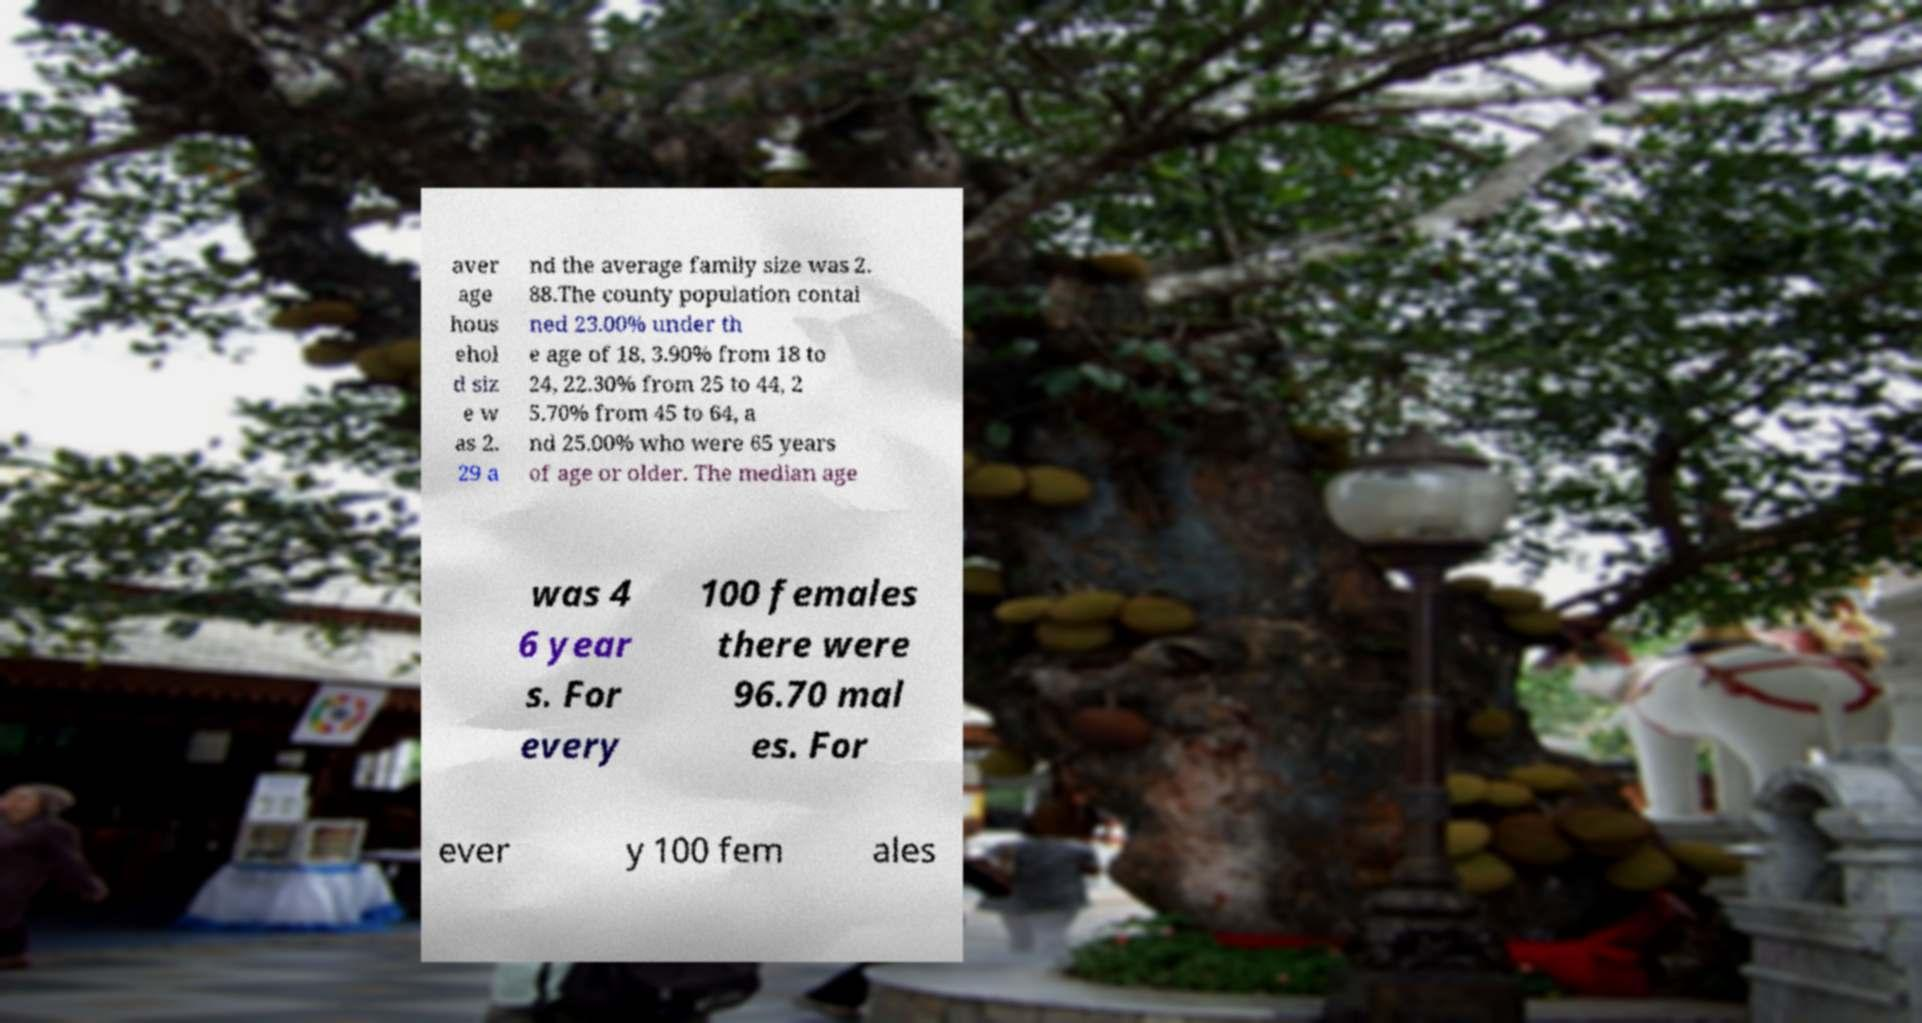Please read and relay the text visible in this image. What does it say? aver age hous ehol d siz e w as 2. 29 a nd the average family size was 2. 88.The county population contai ned 23.00% under th e age of 18, 3.90% from 18 to 24, 22.30% from 25 to 44, 2 5.70% from 45 to 64, a nd 25.00% who were 65 years of age or older. The median age was 4 6 year s. For every 100 females there were 96.70 mal es. For ever y 100 fem ales 